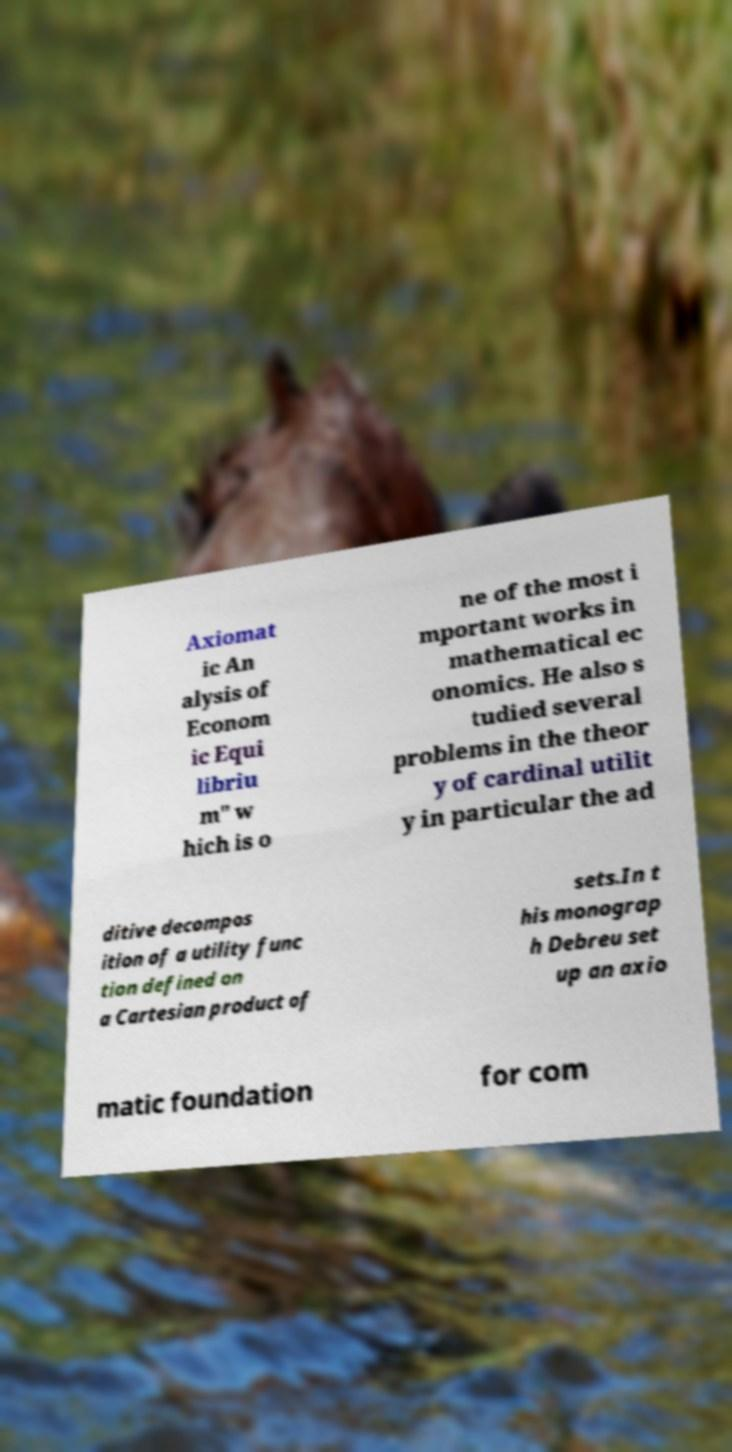What messages or text are displayed in this image? I need them in a readable, typed format. Axiomat ic An alysis of Econom ic Equi libriu m" w hich is o ne of the most i mportant works in mathematical ec onomics. He also s tudied several problems in the theor y of cardinal utilit y in particular the ad ditive decompos ition of a utility func tion defined on a Cartesian product of sets.In t his monograp h Debreu set up an axio matic foundation for com 